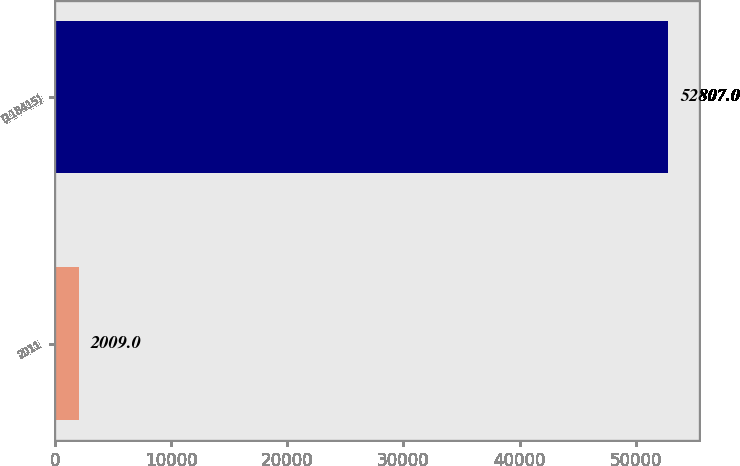Convert chart to OTSL. <chart><loc_0><loc_0><loc_500><loc_500><bar_chart><fcel>2011<fcel>(118415)<nl><fcel>2009<fcel>52807<nl></chart> 